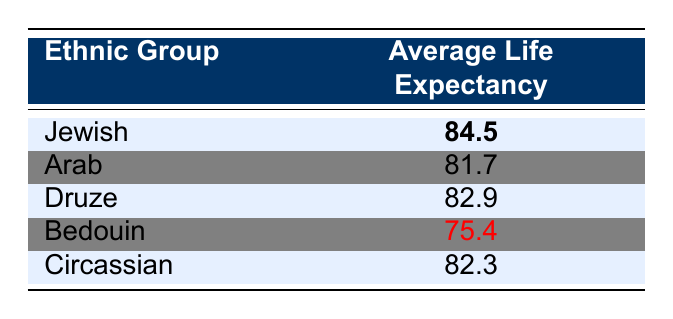What is the average life expectancy of the Jewish ethnic group? The table directly lists the average life expectancy for the Jewish ethnic group as 84.5 years.
Answer: 84.5 Which ethnic group has the lowest average life expectancy? The table shows that the Bedouin ethnic group has the lowest average life expectancy listed at 75.4 years.
Answer: Bedouin What is the average life expectancy of the Druze and Circassian ethnic groups combined? To find the combined average, we sum their average life expectancies: Druze (82.9) + Circassian (82.3) = 165.2, then divide by 2 to find the average: 165.2 / 2 = 82.6.
Answer: 82.6 Is the average life expectancy of Arabs greater than that of Druze? The average life expectancy for Arabs is 81.7 years, while for Druze it is 82.9 years. Therefore, 81.7 is less than 82.9.
Answer: No What is the difference in life expectancy between the Jewish and Bedouin ethnic groups? The life expectancy for the Jewish ethnic group is 84.5 years and for the Bedouin it is 75.4 years. The difference is calculated as 84.5 - 75.4 = 9.1 years.
Answer: 9.1 What percentage do the Druze and Circassian groups' average life expectancies contribute to the Jewish group's average life expectancy? First, we find the sum of Druze and Circassian: 82.9 + 82.3 = 165.2. To find the percentage out of Jewish's average (84.5), we calculate (165.2 / (84.5 * 2)) * 100. That gives us approximately 97.9%.
Answer: 97.9% Is it true that the average life expectancy of Bedouins is greater than Druze? The average life expectancy for Bedouins is 75.4 years, while for Druze it is 82.9 years, indicating the Bedouin average is lower.
Answer: No What ethnic group has a higher average life expectancy, the Arab or the Bedouin? The average life expectancy of Arabs is 81.7 years, while Bedouins have 75.4 years. Since 81.7 is greater than 75.4, Arabs have a higher average life expectancy.
Answer: Arab What is the average life expectancy of the three ethnic groups with the highest life expectancies combined? The three groups with the highest average life expectancies are Jewish (84.5), Druze (82.9), and Circassian (82.3). Adding these gives 84.5 + 82.9 + 82.3 = 249.7, then dividing by 3 gives us 249.7 / 3 = 83.23.
Answer: 83.23 